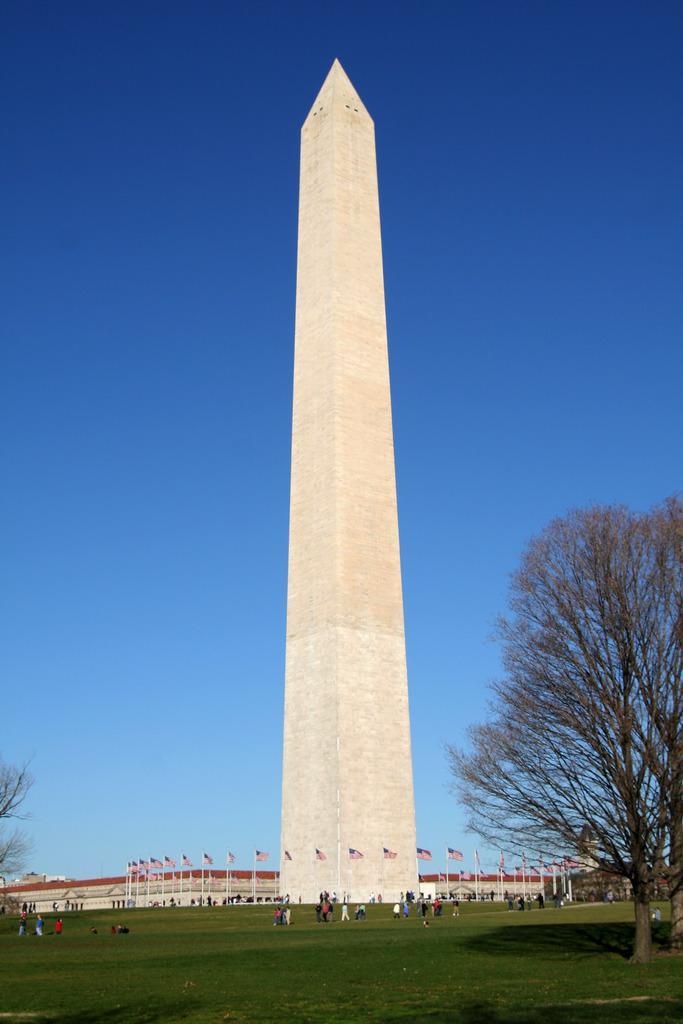Describe this image in one or two sentences. On the right there are trees. In the background there are few persons standing and walking on the grass. In the background we can see poles,flags,tower,building and sky. 